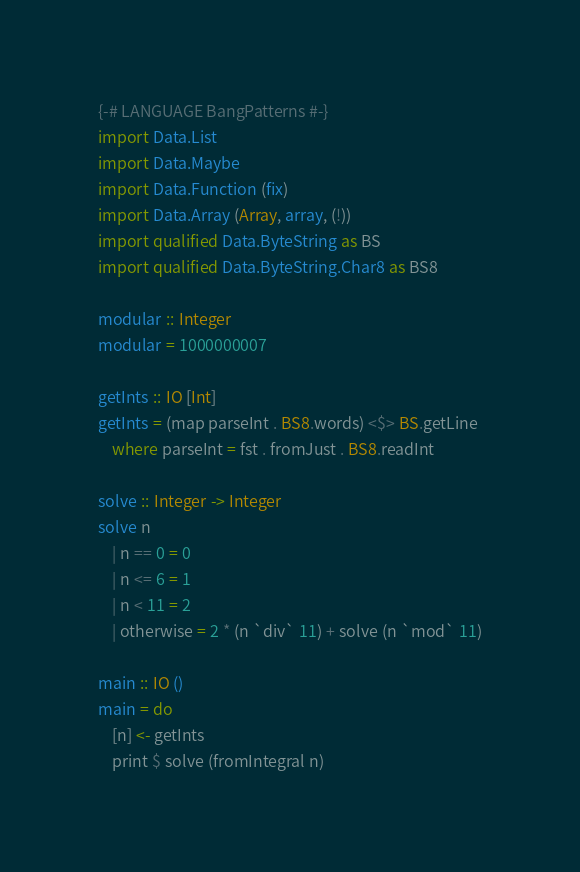Convert code to text. <code><loc_0><loc_0><loc_500><loc_500><_Haskell_>{-# LANGUAGE BangPatterns #-}
import Data.List
import Data.Maybe
import Data.Function (fix)
import Data.Array (Array, array, (!))
import qualified Data.ByteString as BS
import qualified Data.ByteString.Char8 as BS8

modular :: Integer
modular = 1000000007
 
getInts :: IO [Int]
getInts = (map parseInt . BS8.words) <$> BS.getLine 
    where parseInt = fst . fromJust . BS8.readInt

solve :: Integer -> Integer
solve n
    | n == 0 = 0
    | n <= 6 = 1
    | n < 11 = 2
    | otherwise = 2 * (n `div` 11) + solve (n `mod` 11)

main :: IO ()
main = do
    [n] <- getInts
    print $ solve (fromIntegral n)</code> 